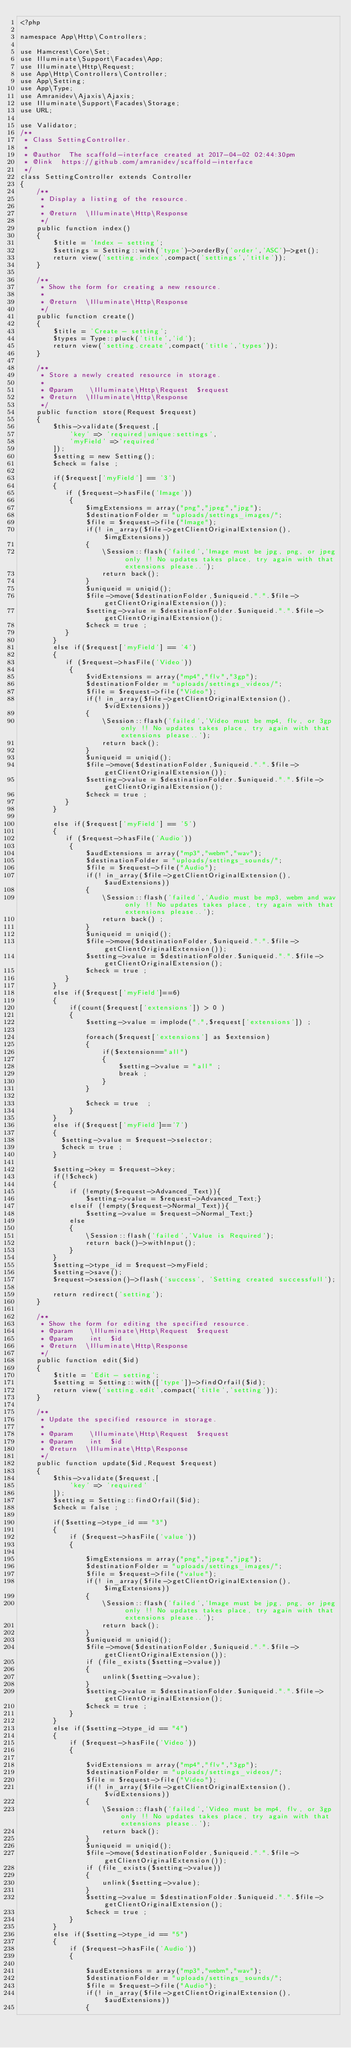Convert code to text. <code><loc_0><loc_0><loc_500><loc_500><_PHP_><?php

namespace App\Http\Controllers;

use Hamcrest\Core\Set;
use Illuminate\Support\Facades\App;
use Illuminate\Http\Request;
use App\Http\Controllers\Controller;
use App\Setting;
use App\Type;
use Amranidev\Ajaxis\Ajaxis;
use Illuminate\Support\Facades\Storage;
use URL;

use Validator;
/**
 * Class SettingController.
 *
 * @author  The scaffold-interface created at 2017-04-02 02:44:30pm
 * @link  https://github.com/amranidev/scaffold-interface
 */
class SettingController extends Controller
{
    /**
     * Display a listing of the resource.
     *
     * @return  \Illuminate\Http\Response
     */
    public function index()
    {
        $title = 'Index - setting';
        $settings = Setting::with('type')->orderBy('order','ASC')->get();
        return view('setting.index',compact('settings','title'));
    }

    /**
     * Show the form for creating a new resource.
     *
     * @return  \Illuminate\Http\Response
     */
    public function create()
    {
        $title = 'Create - setting';
        $types = Type::pluck('title','id');
        return view('setting.create',compact('title','types'));
    }

    /**
     * Store a newly created resource in storage.
     *
     * @param    \Illuminate\Http\Request  $request
     * @return  \Illuminate\Http\Response
     */
    public function store(Request $request)
    {
        $this->validate($request,[
            'key' => 'required|unique:settings',
            'myField' =>'required'
        ]);
        $setting = new Setting();
        $check = false ;

        if($request['myField'] == '3')
        {
           if ($request->hasFile('Image'))
            {
                $imgExtensions = array("png","jpeg","jpg");
                $destinationFolder = "uploads/settings_images/";
                $file = $request->file("Image");
                if(! in_array($file->getClientOriginalExtension(),$imgExtensions))
                {
                    \Session::flash('failed','Image must be jpg, png, or jpeg only !! No updates takes place, try again with that extensions please..');
                    return back();
                }
                $uniqueid = uniqid();
                $file->move($destinationFolder,$uniqueid.".".$file->getClientOriginalExtension());
                $setting->value = $destinationFolder.$uniqueid.".".$file->getClientOriginalExtension();
                $check = true ;
           }
        }
        else if($request['myField'] == '4')
        {
           if ($request->hasFile('Video'))
            {
                $vidExtensions = array("mp4","flv","3gp");
                $destinationFolder = "uploads/settings_videos/";
                $file = $request->file("Video");
                if(! in_array($file->getClientOriginalExtension(),$vidExtensions))
                {
                    \Session::flash('failed','Video must be mp4, flv, or 3gp only !! No updates takes place, try again with that extensions please..');
                    return back();
                }
                $uniqueid = uniqid();
                $file->move($destinationFolder,$uniqueid.".".$file->getClientOriginalExtension());
                $setting->value = $destinationFolder.$uniqueid.".".$file->getClientOriginalExtension();
                $check = true ;
           }
        }

        else if($request['myField'] == '5')
        {
           if ($request->hasFile('Audio'))
            {
                $audExtensions = array("mp3","webm","wav");
                $destinationFolder = "uploads/settings_sounds/";
                $file = $request->file("Audio");
                if(! in_array($file->getClientOriginalExtension(),$audExtensions))
                {
                    \Session::flash('failed','Audio must be mp3, webm and wav only !! No updates takes place, try again with that extensions please..');
                    return back() ;
                }
                $uniqueid = uniqid();
                $file->move($destinationFolder,$uniqueid.".".$file->getClientOriginalExtension());
                $setting->value = $destinationFolder.$uniqueid.".".$file->getClientOriginalExtension();
                $check = true ;
           }
        }
        else if($request['myField']==6)
        {
            if(count($request['extensions']) > 0 )
            {
                $setting->value = implode(",",$request['extensions']) ;

                foreach($request['extensions'] as $extension)
                {
                    if($extension=="all")
                    {
                        $setting->value = "all" ;
                        break ;
                    }
                }

                $check = true  ;
            }
        }
        else if($request['myField']=='7')
        {
          $setting->value = $request->selector;
          $check = true ;
        }

        $setting->key = $request->key;
        if(!$check)
        {
            if (!empty($request->Advanced_Text)){
                $setting->value = $request->Advanced_Text;}
            elseif (!empty($request->Normal_Text)){
                $setting->value = $request->Normal_Text;}
            else
            {
                \Session::flash('failed','Value is Required');
                return back()->withInput();
            }
        }
        $setting->type_id = $request->myField;
        $setting->save();
        $request->session()->flash('success', 'Setting created successfull');

        return redirect('setting');
    }

    /**
     * Show the form for editing the specified resource.
     * @param    \Illuminate\Http\Request  $request
     * @param    int  $id
     * @return  \Illuminate\Http\Response
     */
    public function edit($id)
    {
        $title = 'Edit - setting';
        $setting = Setting::with(['type'])->findOrfail($id);
        return view('setting.edit',compact('title','setting'));
    }

    /**
     * Update the specified resource in storage.
     *
     * @param    \Illuminate\Http\Request  $request
     * @param    int  $id
     * @return  \Illuminate\Http\Response
     */
    public function update($id,Request $request)
    {
        $this->validate($request,[
            'key' => 'required'
        ]);
        $setting = Setting::findOrfail($id);
        $check = false ;

        if($setting->type_id == "3")
        {
            if ($request->hasFile('value'))
            {

                $imgExtensions = array("png","jpeg","jpg");
                $destinationFolder = "uploads/settings_images/";
                $file = $request->file("value");
                if(! in_array($file->getClientOriginalExtension(),$imgExtensions))
                {
                    \Session::flash('failed','Image must be jpg, png, or jpeg only !! No updates takes place, try again with that extensions please..');
                    return back();
                }
                $uniqueid = uniqid();
                $file->move($destinationFolder,$uniqueid.".".$file->getClientOriginalExtension());
                if (file_exists($setting->value))
                {
                    unlink($setting->value);
                }
                $setting->value = $destinationFolder.$uniqueid.".".$file->getClientOriginalExtension();
                $check = true ;
            }
        }
        else if($setting->type_id == "4")
        {
            if ($request->hasFile('Video'))
            {

                $vidExtensions = array("mp4","flv","3gp");
                $destinationFolder = "uploads/settings_videos/";
                $file = $request->file("Video");
                if(! in_array($file->getClientOriginalExtension(),$vidExtensions))
                {
                    \Session::flash('failed','Video must be mp4, flv, or 3gp only !! No updates takes place, try again with that extensions please..');
                    return back();
                }
                $uniqueid = uniqid();
                $file->move($destinationFolder,$uniqueid.".".$file->getClientOriginalExtension());
                if (file_exists($setting->value))
                {
                    unlink($setting->value);
                }
                $setting->value = $destinationFolder.$uniqueid.".".$file->getClientOriginalExtension();
                $check = true ;
            }
        }
        else if($setting->type_id == "5")
        {
            if ($request->hasFile('Audio'))
            {

                $audExtensions = array("mp3","webm","wav");
                $destinationFolder = "uploads/settings_sounds/";
                $file = $request->file("Audio");
                if(! in_array($file->getClientOriginalExtension(),$audExtensions))
                {</code> 